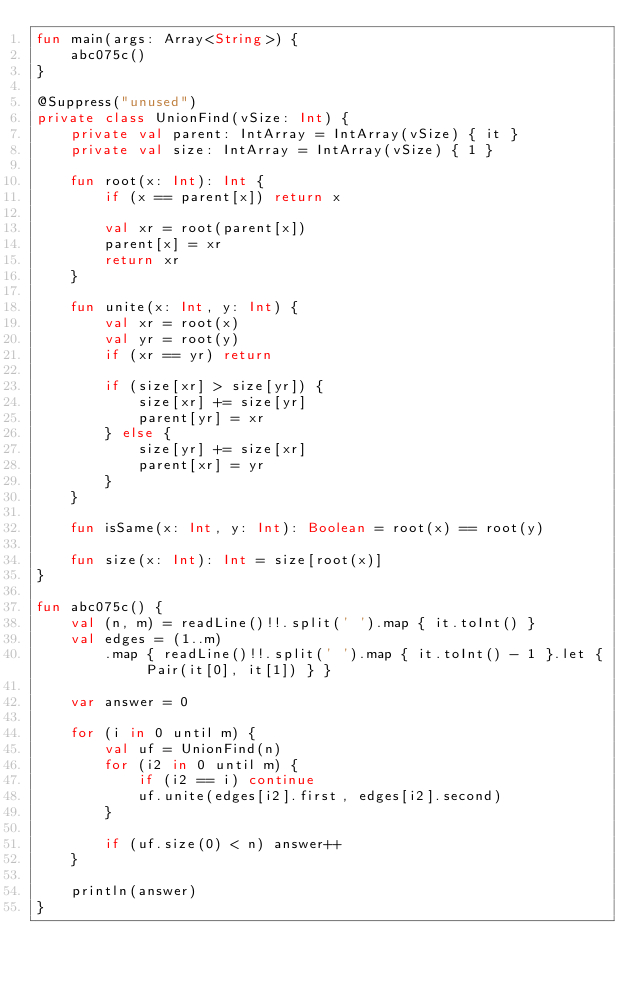Convert code to text. <code><loc_0><loc_0><loc_500><loc_500><_Kotlin_>fun main(args: Array<String>) {
    abc075c()
}

@Suppress("unused")
private class UnionFind(vSize: Int) {
    private val parent: IntArray = IntArray(vSize) { it }
    private val size: IntArray = IntArray(vSize) { 1 }

    fun root(x: Int): Int {
        if (x == parent[x]) return x

        val xr = root(parent[x])
        parent[x] = xr
        return xr
    }

    fun unite(x: Int, y: Int) {
        val xr = root(x)
        val yr = root(y)
        if (xr == yr) return

        if (size[xr] > size[yr]) {
            size[xr] += size[yr]
            parent[yr] = xr
        } else {
            size[yr] += size[xr]
            parent[xr] = yr
        }
    }

    fun isSame(x: Int, y: Int): Boolean = root(x) == root(y)

    fun size(x: Int): Int = size[root(x)]
}

fun abc075c() {
    val (n, m) = readLine()!!.split(' ').map { it.toInt() }
    val edges = (1..m)
        .map { readLine()!!.split(' ').map { it.toInt() - 1 }.let { Pair(it[0], it[1]) } }

    var answer = 0

    for (i in 0 until m) {
        val uf = UnionFind(n)
        for (i2 in 0 until m) {
            if (i2 == i) continue
            uf.unite(edges[i2].first, edges[i2].second)
        }

        if (uf.size(0) < n) answer++
    }

    println(answer)
}
</code> 